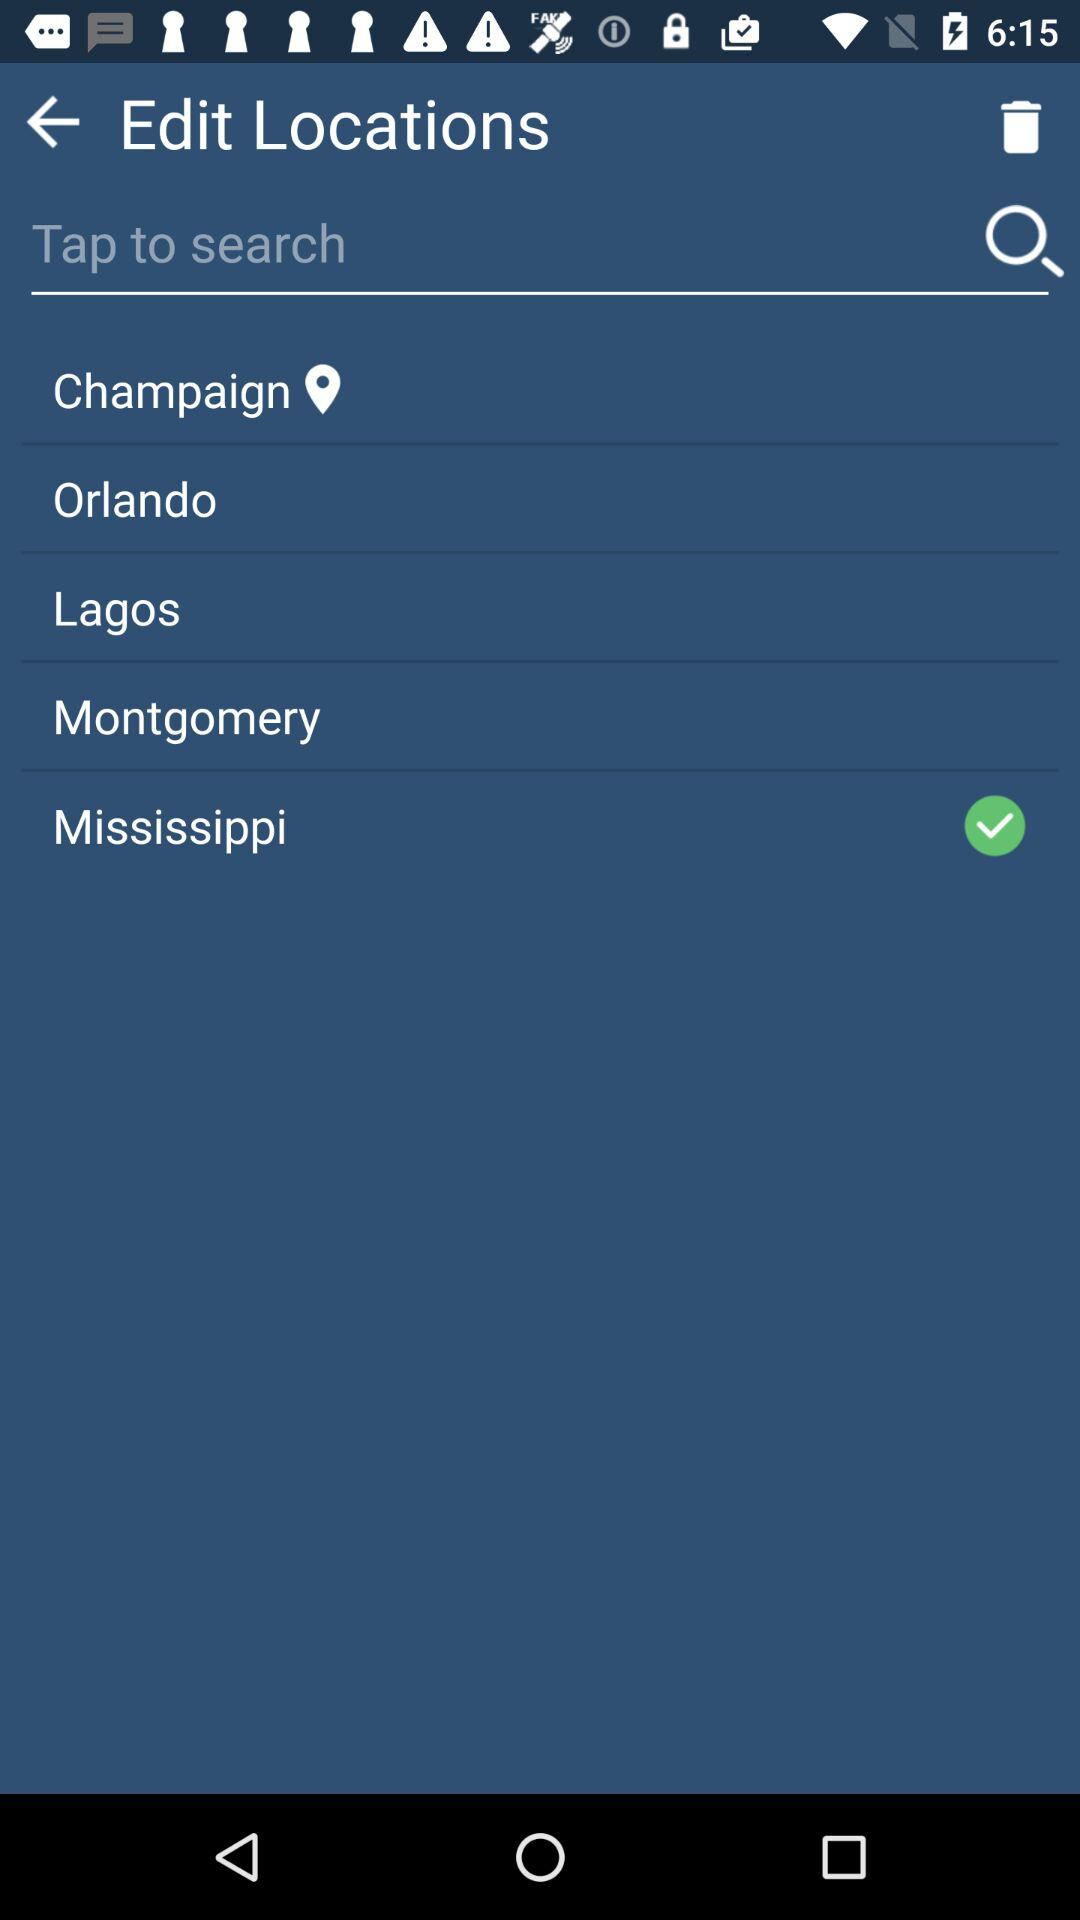Which locations have been trashed?
When the provided information is insufficient, respond with <no answer>. <no answer> 